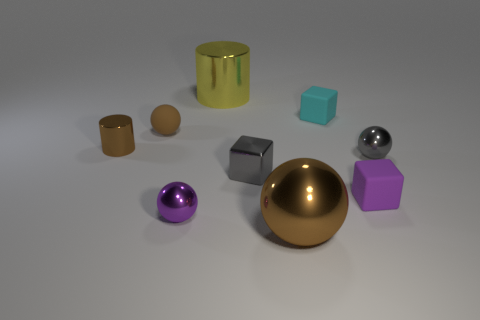Is the size of the cyan object the same as the gray metallic object that is left of the tiny gray metallic ball?
Your response must be concise. Yes. The big object in front of the metallic cylinder in front of the large cylinder is what color?
Your response must be concise. Brown. Do the shiny block and the gray metal sphere have the same size?
Provide a succinct answer. Yes. The sphere that is behind the small purple sphere and on the right side of the tiny purple sphere is what color?
Provide a succinct answer. Gray. What size is the cyan thing?
Offer a very short reply. Small. Is the color of the metallic ball in front of the purple ball the same as the matte ball?
Make the answer very short. Yes. Is the number of purple metal things behind the yellow metallic cylinder greater than the number of cyan things that are on the right side of the cyan block?
Ensure brevity in your answer.  No. Are there more small brown objects than large brown matte cubes?
Your answer should be compact. Yes. There is a matte thing that is both right of the small gray cube and behind the small gray ball; what is its size?
Offer a terse response. Small. What shape is the tiny purple shiny object?
Keep it short and to the point. Sphere. 